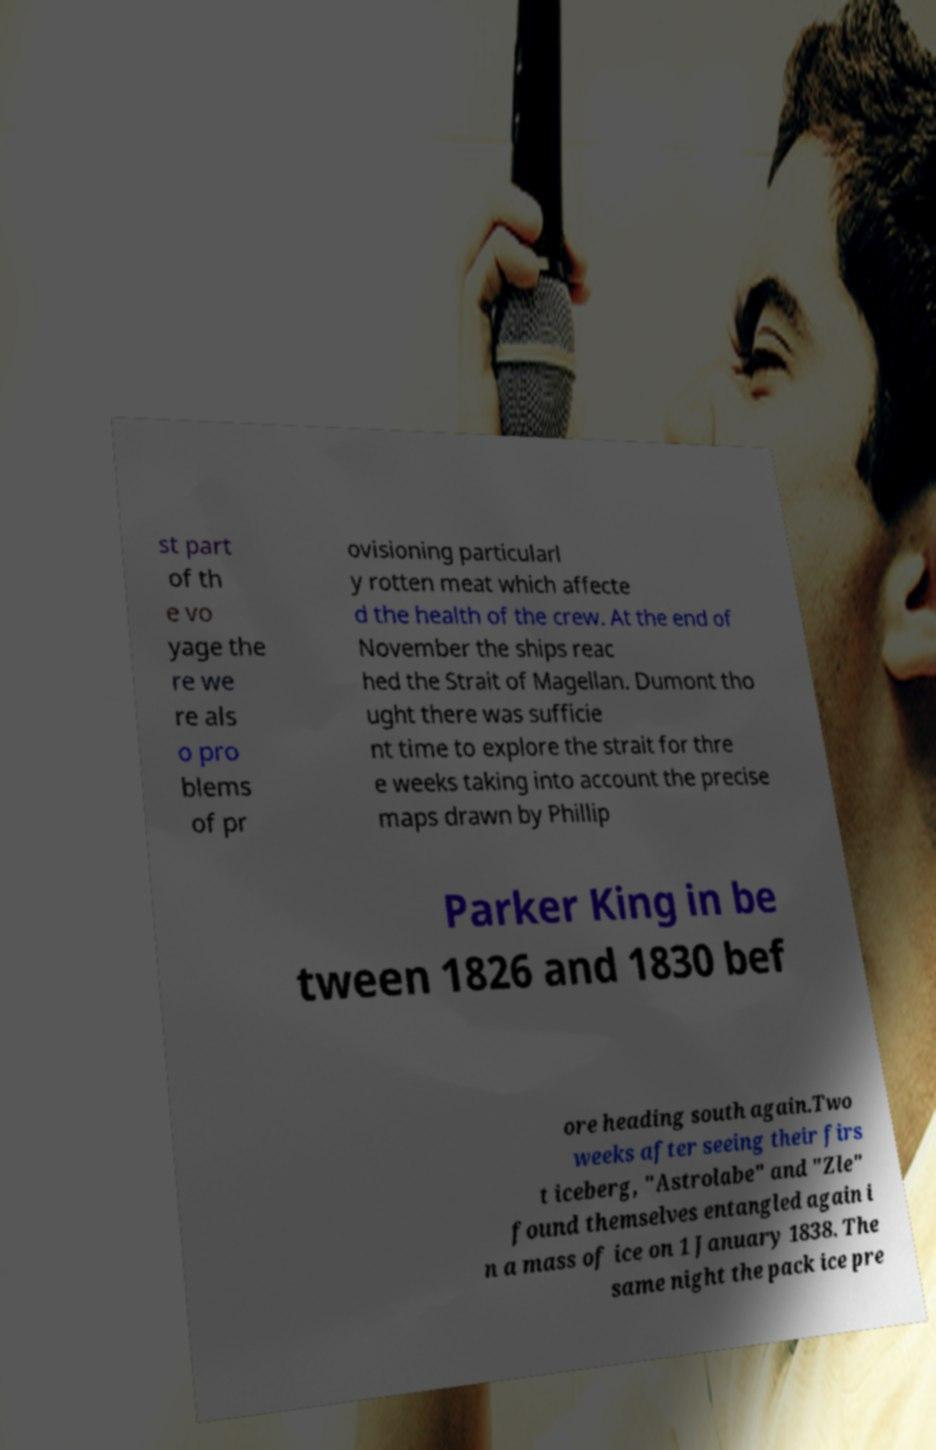Please identify and transcribe the text found in this image. st part of th e vo yage the re we re als o pro blems of pr ovisioning particularl y rotten meat which affecte d the health of the crew. At the end of November the ships reac hed the Strait of Magellan. Dumont tho ught there was sufficie nt time to explore the strait for thre e weeks taking into account the precise maps drawn by Phillip Parker King in be tween 1826 and 1830 bef ore heading south again.Two weeks after seeing their firs t iceberg, "Astrolabe" and "Zle" found themselves entangled again i n a mass of ice on 1 January 1838. The same night the pack ice pre 